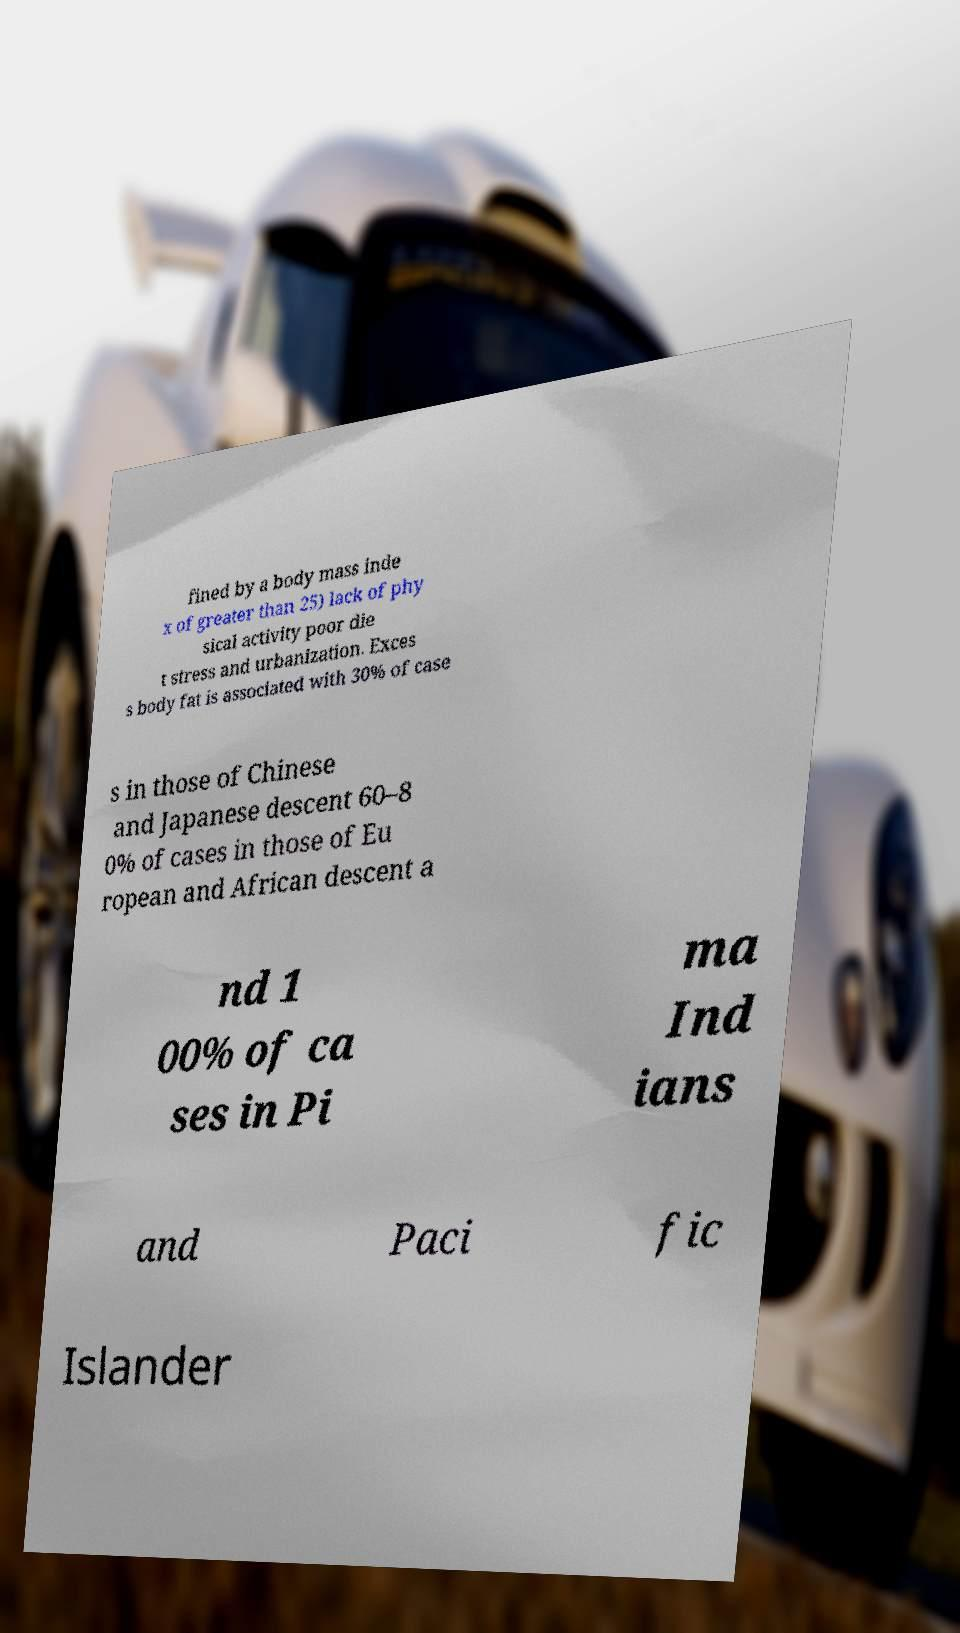Can you accurately transcribe the text from the provided image for me? fined by a body mass inde x of greater than 25) lack of phy sical activity poor die t stress and urbanization. Exces s body fat is associated with 30% of case s in those of Chinese and Japanese descent 60–8 0% of cases in those of Eu ropean and African descent a nd 1 00% of ca ses in Pi ma Ind ians and Paci fic Islander 